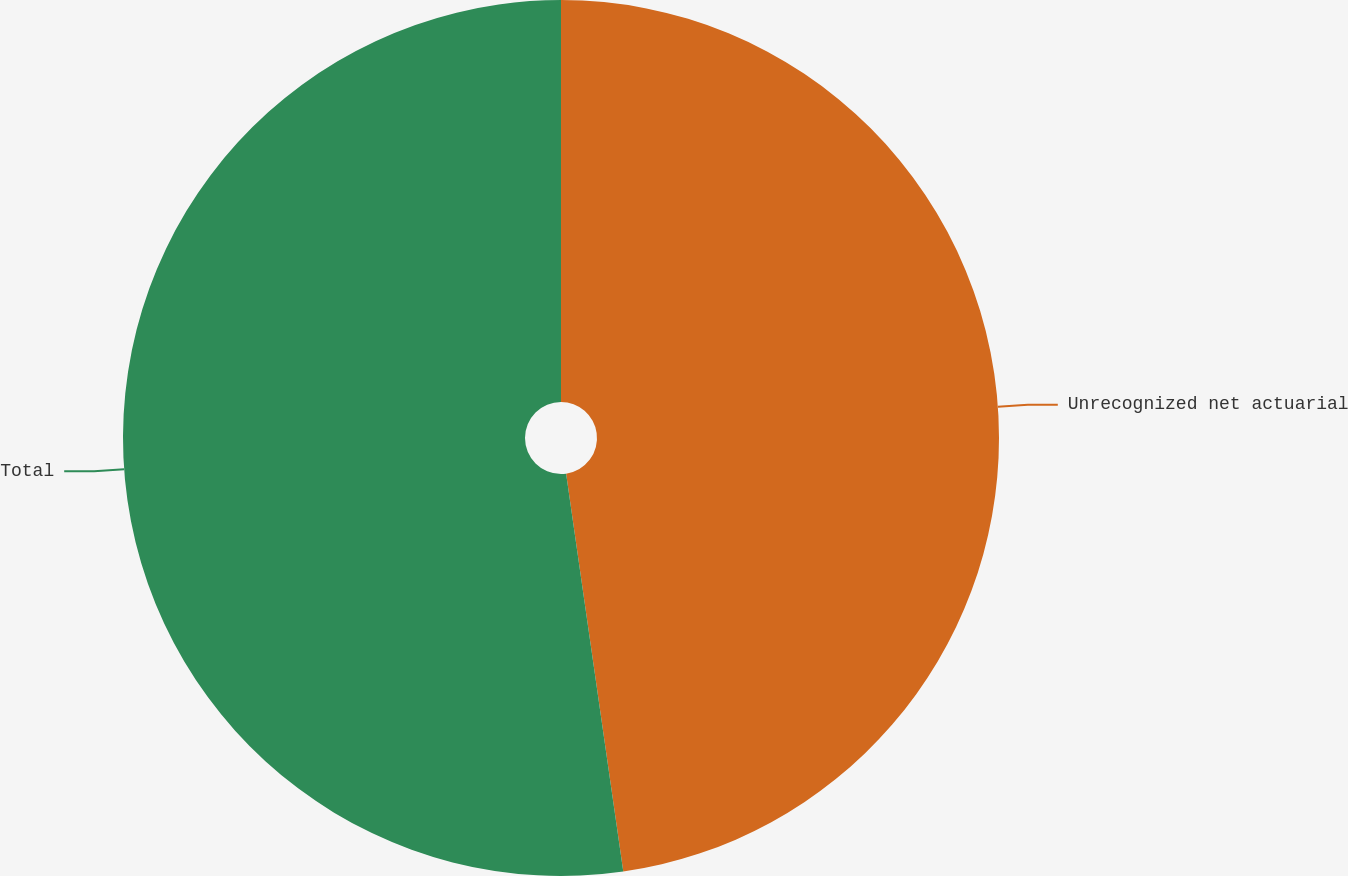Convert chart to OTSL. <chart><loc_0><loc_0><loc_500><loc_500><pie_chart><fcel>Unrecognized net actuarial<fcel>Total<nl><fcel>47.73%<fcel>52.27%<nl></chart> 